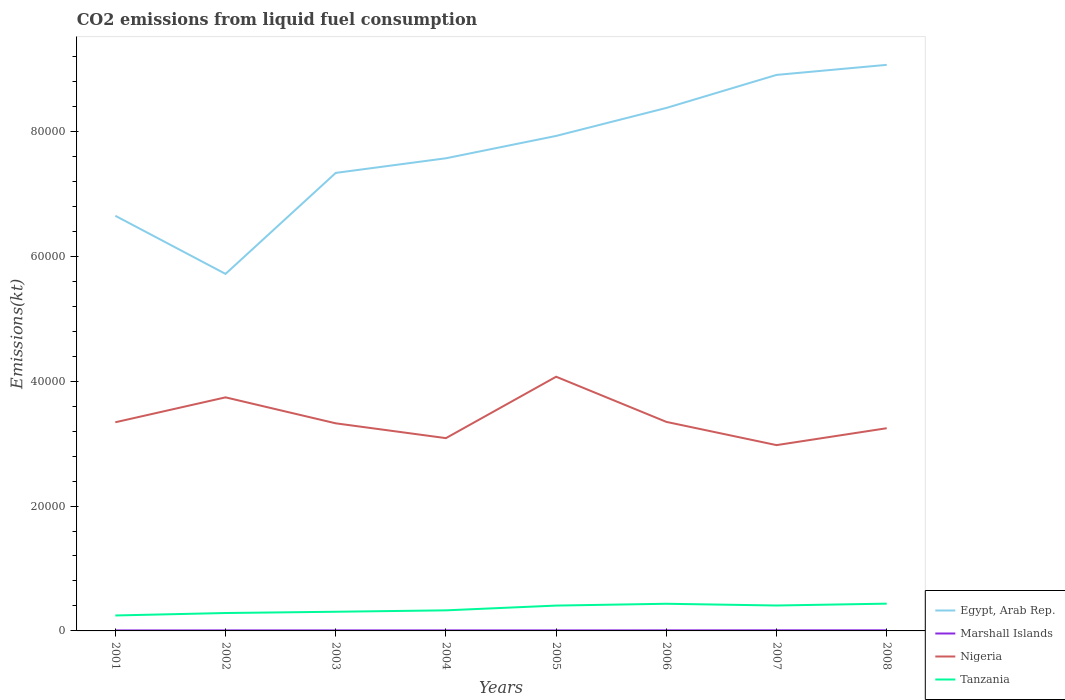Is the number of lines equal to the number of legend labels?
Give a very brief answer. Yes. Across all years, what is the maximum amount of CO2 emitted in Egypt, Arab Rep.?
Ensure brevity in your answer.  5.72e+04. What is the total amount of CO2 emitted in Marshall Islands in the graph?
Offer a terse response. -11. What is the difference between the highest and the second highest amount of CO2 emitted in Marshall Islands?
Ensure brevity in your answer.  18.34. What is the difference between the highest and the lowest amount of CO2 emitted in Egypt, Arab Rep.?
Keep it short and to the point. 4. How many years are there in the graph?
Offer a very short reply. 8. Are the values on the major ticks of Y-axis written in scientific E-notation?
Provide a succinct answer. No. Does the graph contain grids?
Offer a terse response. No. How many legend labels are there?
Make the answer very short. 4. What is the title of the graph?
Give a very brief answer. CO2 emissions from liquid fuel consumption. What is the label or title of the Y-axis?
Your answer should be compact. Emissions(kt). What is the Emissions(kt) of Egypt, Arab Rep. in 2001?
Offer a terse response. 6.65e+04. What is the Emissions(kt) of Marshall Islands in 2001?
Make the answer very short. 80.67. What is the Emissions(kt) of Nigeria in 2001?
Keep it short and to the point. 3.34e+04. What is the Emissions(kt) in Tanzania in 2001?
Offer a very short reply. 2475.22. What is the Emissions(kt) in Egypt, Arab Rep. in 2002?
Ensure brevity in your answer.  5.72e+04. What is the Emissions(kt) of Marshall Islands in 2002?
Offer a terse response. 84.34. What is the Emissions(kt) of Nigeria in 2002?
Make the answer very short. 3.74e+04. What is the Emissions(kt) of Tanzania in 2002?
Offer a terse response. 2867.59. What is the Emissions(kt) in Egypt, Arab Rep. in 2003?
Provide a succinct answer. 7.34e+04. What is the Emissions(kt) in Marshall Islands in 2003?
Your answer should be compact. 84.34. What is the Emissions(kt) in Nigeria in 2003?
Keep it short and to the point. 3.32e+04. What is the Emissions(kt) of Tanzania in 2003?
Your answer should be very brief. 3069.28. What is the Emissions(kt) of Egypt, Arab Rep. in 2004?
Provide a short and direct response. 7.57e+04. What is the Emissions(kt) of Marshall Islands in 2004?
Ensure brevity in your answer.  88.01. What is the Emissions(kt) of Nigeria in 2004?
Keep it short and to the point. 3.09e+04. What is the Emissions(kt) in Tanzania in 2004?
Give a very brief answer. 3296.63. What is the Emissions(kt) of Egypt, Arab Rep. in 2005?
Your answer should be compact. 7.93e+04. What is the Emissions(kt) in Marshall Islands in 2005?
Provide a succinct answer. 84.34. What is the Emissions(kt) in Nigeria in 2005?
Offer a very short reply. 4.07e+04. What is the Emissions(kt) of Tanzania in 2005?
Your response must be concise. 4059.37. What is the Emissions(kt) in Egypt, Arab Rep. in 2006?
Ensure brevity in your answer.  8.38e+04. What is the Emissions(kt) of Marshall Islands in 2006?
Provide a succinct answer. 91.67. What is the Emissions(kt) in Nigeria in 2006?
Offer a very short reply. 3.35e+04. What is the Emissions(kt) in Tanzania in 2006?
Make the answer very short. 4349.06. What is the Emissions(kt) of Egypt, Arab Rep. in 2007?
Offer a terse response. 8.90e+04. What is the Emissions(kt) in Marshall Islands in 2007?
Offer a very short reply. 99.01. What is the Emissions(kt) in Nigeria in 2007?
Provide a succinct answer. 2.98e+04. What is the Emissions(kt) in Tanzania in 2007?
Your response must be concise. 4070.37. What is the Emissions(kt) in Egypt, Arab Rep. in 2008?
Provide a short and direct response. 9.07e+04. What is the Emissions(kt) of Marshall Islands in 2008?
Keep it short and to the point. 99.01. What is the Emissions(kt) in Nigeria in 2008?
Ensure brevity in your answer.  3.25e+04. What is the Emissions(kt) of Tanzania in 2008?
Your answer should be very brief. 4367.4. Across all years, what is the maximum Emissions(kt) of Egypt, Arab Rep.?
Keep it short and to the point. 9.07e+04. Across all years, what is the maximum Emissions(kt) of Marshall Islands?
Keep it short and to the point. 99.01. Across all years, what is the maximum Emissions(kt) of Nigeria?
Offer a terse response. 4.07e+04. Across all years, what is the maximum Emissions(kt) of Tanzania?
Your response must be concise. 4367.4. Across all years, what is the minimum Emissions(kt) in Egypt, Arab Rep.?
Provide a succinct answer. 5.72e+04. Across all years, what is the minimum Emissions(kt) of Marshall Islands?
Your answer should be very brief. 80.67. Across all years, what is the minimum Emissions(kt) in Nigeria?
Keep it short and to the point. 2.98e+04. Across all years, what is the minimum Emissions(kt) in Tanzania?
Provide a short and direct response. 2475.22. What is the total Emissions(kt) of Egypt, Arab Rep. in the graph?
Ensure brevity in your answer.  6.15e+05. What is the total Emissions(kt) in Marshall Islands in the graph?
Provide a short and direct response. 711.4. What is the total Emissions(kt) of Nigeria in the graph?
Provide a succinct answer. 2.71e+05. What is the total Emissions(kt) in Tanzania in the graph?
Your answer should be very brief. 2.86e+04. What is the difference between the Emissions(kt) of Egypt, Arab Rep. in 2001 and that in 2002?
Provide a short and direct response. 9306.85. What is the difference between the Emissions(kt) of Marshall Islands in 2001 and that in 2002?
Offer a terse response. -3.67. What is the difference between the Emissions(kt) in Nigeria in 2001 and that in 2002?
Provide a succinct answer. -3989.7. What is the difference between the Emissions(kt) in Tanzania in 2001 and that in 2002?
Offer a very short reply. -392.37. What is the difference between the Emissions(kt) in Egypt, Arab Rep. in 2001 and that in 2003?
Your answer should be compact. -6868.29. What is the difference between the Emissions(kt) in Marshall Islands in 2001 and that in 2003?
Your answer should be very brief. -3.67. What is the difference between the Emissions(kt) in Nigeria in 2001 and that in 2003?
Your response must be concise. 168.68. What is the difference between the Emissions(kt) of Tanzania in 2001 and that in 2003?
Give a very brief answer. -594.05. What is the difference between the Emissions(kt) of Egypt, Arab Rep. in 2001 and that in 2004?
Your answer should be compact. -9211.5. What is the difference between the Emissions(kt) of Marshall Islands in 2001 and that in 2004?
Your answer should be very brief. -7.33. What is the difference between the Emissions(kt) of Nigeria in 2001 and that in 2004?
Offer a terse response. 2541.23. What is the difference between the Emissions(kt) in Tanzania in 2001 and that in 2004?
Make the answer very short. -821.41. What is the difference between the Emissions(kt) of Egypt, Arab Rep. in 2001 and that in 2005?
Give a very brief answer. -1.28e+04. What is the difference between the Emissions(kt) in Marshall Islands in 2001 and that in 2005?
Make the answer very short. -3.67. What is the difference between the Emissions(kt) of Nigeria in 2001 and that in 2005?
Offer a very short reply. -7293.66. What is the difference between the Emissions(kt) in Tanzania in 2001 and that in 2005?
Provide a short and direct response. -1584.14. What is the difference between the Emissions(kt) in Egypt, Arab Rep. in 2001 and that in 2006?
Make the answer very short. -1.73e+04. What is the difference between the Emissions(kt) in Marshall Islands in 2001 and that in 2006?
Provide a succinct answer. -11. What is the difference between the Emissions(kt) of Nigeria in 2001 and that in 2006?
Offer a terse response. -62.34. What is the difference between the Emissions(kt) of Tanzania in 2001 and that in 2006?
Keep it short and to the point. -1873.84. What is the difference between the Emissions(kt) in Egypt, Arab Rep. in 2001 and that in 2007?
Your answer should be compact. -2.26e+04. What is the difference between the Emissions(kt) of Marshall Islands in 2001 and that in 2007?
Provide a succinct answer. -18.34. What is the difference between the Emissions(kt) in Nigeria in 2001 and that in 2007?
Your response must be concise. 3659.67. What is the difference between the Emissions(kt) of Tanzania in 2001 and that in 2007?
Offer a terse response. -1595.14. What is the difference between the Emissions(kt) in Egypt, Arab Rep. in 2001 and that in 2008?
Give a very brief answer. -2.42e+04. What is the difference between the Emissions(kt) in Marshall Islands in 2001 and that in 2008?
Offer a terse response. -18.34. What is the difference between the Emissions(kt) in Nigeria in 2001 and that in 2008?
Make the answer very short. 953.42. What is the difference between the Emissions(kt) of Tanzania in 2001 and that in 2008?
Keep it short and to the point. -1892.17. What is the difference between the Emissions(kt) in Egypt, Arab Rep. in 2002 and that in 2003?
Keep it short and to the point. -1.62e+04. What is the difference between the Emissions(kt) of Nigeria in 2002 and that in 2003?
Provide a short and direct response. 4158.38. What is the difference between the Emissions(kt) in Tanzania in 2002 and that in 2003?
Offer a very short reply. -201.69. What is the difference between the Emissions(kt) of Egypt, Arab Rep. in 2002 and that in 2004?
Ensure brevity in your answer.  -1.85e+04. What is the difference between the Emissions(kt) of Marshall Islands in 2002 and that in 2004?
Ensure brevity in your answer.  -3.67. What is the difference between the Emissions(kt) in Nigeria in 2002 and that in 2004?
Offer a very short reply. 6530.93. What is the difference between the Emissions(kt) of Tanzania in 2002 and that in 2004?
Offer a very short reply. -429.04. What is the difference between the Emissions(kt) in Egypt, Arab Rep. in 2002 and that in 2005?
Offer a terse response. -2.21e+04. What is the difference between the Emissions(kt) in Marshall Islands in 2002 and that in 2005?
Give a very brief answer. 0. What is the difference between the Emissions(kt) of Nigeria in 2002 and that in 2005?
Keep it short and to the point. -3303.97. What is the difference between the Emissions(kt) of Tanzania in 2002 and that in 2005?
Provide a short and direct response. -1191.78. What is the difference between the Emissions(kt) in Egypt, Arab Rep. in 2002 and that in 2006?
Give a very brief answer. -2.66e+04. What is the difference between the Emissions(kt) in Marshall Islands in 2002 and that in 2006?
Your response must be concise. -7.33. What is the difference between the Emissions(kt) of Nigeria in 2002 and that in 2006?
Your response must be concise. 3927.36. What is the difference between the Emissions(kt) in Tanzania in 2002 and that in 2006?
Offer a very short reply. -1481.47. What is the difference between the Emissions(kt) of Egypt, Arab Rep. in 2002 and that in 2007?
Offer a very short reply. -3.19e+04. What is the difference between the Emissions(kt) of Marshall Islands in 2002 and that in 2007?
Your answer should be compact. -14.67. What is the difference between the Emissions(kt) of Nigeria in 2002 and that in 2007?
Give a very brief answer. 7649.36. What is the difference between the Emissions(kt) of Tanzania in 2002 and that in 2007?
Your answer should be very brief. -1202.78. What is the difference between the Emissions(kt) of Egypt, Arab Rep. in 2002 and that in 2008?
Keep it short and to the point. -3.35e+04. What is the difference between the Emissions(kt) of Marshall Islands in 2002 and that in 2008?
Make the answer very short. -14.67. What is the difference between the Emissions(kt) of Nigeria in 2002 and that in 2008?
Your response must be concise. 4943.12. What is the difference between the Emissions(kt) in Tanzania in 2002 and that in 2008?
Make the answer very short. -1499.8. What is the difference between the Emissions(kt) in Egypt, Arab Rep. in 2003 and that in 2004?
Make the answer very short. -2343.21. What is the difference between the Emissions(kt) of Marshall Islands in 2003 and that in 2004?
Offer a terse response. -3.67. What is the difference between the Emissions(kt) in Nigeria in 2003 and that in 2004?
Offer a very short reply. 2372.55. What is the difference between the Emissions(kt) in Tanzania in 2003 and that in 2004?
Your response must be concise. -227.35. What is the difference between the Emissions(kt) in Egypt, Arab Rep. in 2003 and that in 2005?
Your response must be concise. -5922.2. What is the difference between the Emissions(kt) in Marshall Islands in 2003 and that in 2005?
Your answer should be very brief. 0. What is the difference between the Emissions(kt) of Nigeria in 2003 and that in 2005?
Your answer should be compact. -7462.35. What is the difference between the Emissions(kt) in Tanzania in 2003 and that in 2005?
Your answer should be very brief. -990.09. What is the difference between the Emissions(kt) in Egypt, Arab Rep. in 2003 and that in 2006?
Your response must be concise. -1.04e+04. What is the difference between the Emissions(kt) in Marshall Islands in 2003 and that in 2006?
Your answer should be compact. -7.33. What is the difference between the Emissions(kt) of Nigeria in 2003 and that in 2006?
Provide a succinct answer. -231.02. What is the difference between the Emissions(kt) of Tanzania in 2003 and that in 2006?
Your response must be concise. -1279.78. What is the difference between the Emissions(kt) in Egypt, Arab Rep. in 2003 and that in 2007?
Your answer should be compact. -1.57e+04. What is the difference between the Emissions(kt) in Marshall Islands in 2003 and that in 2007?
Your answer should be compact. -14.67. What is the difference between the Emissions(kt) in Nigeria in 2003 and that in 2007?
Your answer should be compact. 3490.98. What is the difference between the Emissions(kt) of Tanzania in 2003 and that in 2007?
Offer a terse response. -1001.09. What is the difference between the Emissions(kt) in Egypt, Arab Rep. in 2003 and that in 2008?
Your answer should be very brief. -1.73e+04. What is the difference between the Emissions(kt) in Marshall Islands in 2003 and that in 2008?
Offer a terse response. -14.67. What is the difference between the Emissions(kt) of Nigeria in 2003 and that in 2008?
Offer a terse response. 784.74. What is the difference between the Emissions(kt) in Tanzania in 2003 and that in 2008?
Provide a succinct answer. -1298.12. What is the difference between the Emissions(kt) in Egypt, Arab Rep. in 2004 and that in 2005?
Provide a short and direct response. -3578.99. What is the difference between the Emissions(kt) in Marshall Islands in 2004 and that in 2005?
Make the answer very short. 3.67. What is the difference between the Emissions(kt) of Nigeria in 2004 and that in 2005?
Keep it short and to the point. -9834.89. What is the difference between the Emissions(kt) of Tanzania in 2004 and that in 2005?
Offer a very short reply. -762.74. What is the difference between the Emissions(kt) in Egypt, Arab Rep. in 2004 and that in 2006?
Your answer should be very brief. -8060.07. What is the difference between the Emissions(kt) in Marshall Islands in 2004 and that in 2006?
Give a very brief answer. -3.67. What is the difference between the Emissions(kt) of Nigeria in 2004 and that in 2006?
Your response must be concise. -2603.57. What is the difference between the Emissions(kt) of Tanzania in 2004 and that in 2006?
Provide a short and direct response. -1052.43. What is the difference between the Emissions(kt) of Egypt, Arab Rep. in 2004 and that in 2007?
Your answer should be very brief. -1.34e+04. What is the difference between the Emissions(kt) in Marshall Islands in 2004 and that in 2007?
Provide a succinct answer. -11. What is the difference between the Emissions(kt) in Nigeria in 2004 and that in 2007?
Make the answer very short. 1118.43. What is the difference between the Emissions(kt) in Tanzania in 2004 and that in 2007?
Make the answer very short. -773.74. What is the difference between the Emissions(kt) in Egypt, Arab Rep. in 2004 and that in 2008?
Your answer should be compact. -1.50e+04. What is the difference between the Emissions(kt) of Marshall Islands in 2004 and that in 2008?
Offer a terse response. -11. What is the difference between the Emissions(kt) of Nigeria in 2004 and that in 2008?
Ensure brevity in your answer.  -1587.81. What is the difference between the Emissions(kt) in Tanzania in 2004 and that in 2008?
Your answer should be very brief. -1070.76. What is the difference between the Emissions(kt) of Egypt, Arab Rep. in 2005 and that in 2006?
Your answer should be compact. -4481.07. What is the difference between the Emissions(kt) of Marshall Islands in 2005 and that in 2006?
Give a very brief answer. -7.33. What is the difference between the Emissions(kt) in Nigeria in 2005 and that in 2006?
Your answer should be very brief. 7231.32. What is the difference between the Emissions(kt) in Tanzania in 2005 and that in 2006?
Offer a very short reply. -289.69. What is the difference between the Emissions(kt) in Egypt, Arab Rep. in 2005 and that in 2007?
Your answer should be compact. -9772.56. What is the difference between the Emissions(kt) of Marshall Islands in 2005 and that in 2007?
Make the answer very short. -14.67. What is the difference between the Emissions(kt) of Nigeria in 2005 and that in 2007?
Ensure brevity in your answer.  1.10e+04. What is the difference between the Emissions(kt) of Tanzania in 2005 and that in 2007?
Make the answer very short. -11. What is the difference between the Emissions(kt) of Egypt, Arab Rep. in 2005 and that in 2008?
Make the answer very short. -1.14e+04. What is the difference between the Emissions(kt) in Marshall Islands in 2005 and that in 2008?
Provide a short and direct response. -14.67. What is the difference between the Emissions(kt) of Nigeria in 2005 and that in 2008?
Give a very brief answer. 8247.08. What is the difference between the Emissions(kt) in Tanzania in 2005 and that in 2008?
Provide a short and direct response. -308.03. What is the difference between the Emissions(kt) in Egypt, Arab Rep. in 2006 and that in 2007?
Keep it short and to the point. -5291.48. What is the difference between the Emissions(kt) of Marshall Islands in 2006 and that in 2007?
Offer a very short reply. -7.33. What is the difference between the Emissions(kt) of Nigeria in 2006 and that in 2007?
Offer a terse response. 3722.01. What is the difference between the Emissions(kt) of Tanzania in 2006 and that in 2007?
Your answer should be compact. 278.69. What is the difference between the Emissions(kt) of Egypt, Arab Rep. in 2006 and that in 2008?
Offer a terse response. -6901.29. What is the difference between the Emissions(kt) in Marshall Islands in 2006 and that in 2008?
Provide a succinct answer. -7.33. What is the difference between the Emissions(kt) of Nigeria in 2006 and that in 2008?
Offer a terse response. 1015.76. What is the difference between the Emissions(kt) in Tanzania in 2006 and that in 2008?
Ensure brevity in your answer.  -18.34. What is the difference between the Emissions(kt) in Egypt, Arab Rep. in 2007 and that in 2008?
Make the answer very short. -1609.81. What is the difference between the Emissions(kt) of Nigeria in 2007 and that in 2008?
Keep it short and to the point. -2706.25. What is the difference between the Emissions(kt) in Tanzania in 2007 and that in 2008?
Your answer should be very brief. -297.03. What is the difference between the Emissions(kt) in Egypt, Arab Rep. in 2001 and the Emissions(kt) in Marshall Islands in 2002?
Offer a very short reply. 6.64e+04. What is the difference between the Emissions(kt) of Egypt, Arab Rep. in 2001 and the Emissions(kt) of Nigeria in 2002?
Offer a terse response. 2.91e+04. What is the difference between the Emissions(kt) of Egypt, Arab Rep. in 2001 and the Emissions(kt) of Tanzania in 2002?
Give a very brief answer. 6.36e+04. What is the difference between the Emissions(kt) in Marshall Islands in 2001 and the Emissions(kt) in Nigeria in 2002?
Provide a succinct answer. -3.73e+04. What is the difference between the Emissions(kt) of Marshall Islands in 2001 and the Emissions(kt) of Tanzania in 2002?
Your response must be concise. -2786.92. What is the difference between the Emissions(kt) of Nigeria in 2001 and the Emissions(kt) of Tanzania in 2002?
Provide a short and direct response. 3.05e+04. What is the difference between the Emissions(kt) of Egypt, Arab Rep. in 2001 and the Emissions(kt) of Marshall Islands in 2003?
Your answer should be compact. 6.64e+04. What is the difference between the Emissions(kt) of Egypt, Arab Rep. in 2001 and the Emissions(kt) of Nigeria in 2003?
Your answer should be very brief. 3.32e+04. What is the difference between the Emissions(kt) of Egypt, Arab Rep. in 2001 and the Emissions(kt) of Tanzania in 2003?
Your answer should be compact. 6.34e+04. What is the difference between the Emissions(kt) in Marshall Islands in 2001 and the Emissions(kt) in Nigeria in 2003?
Provide a succinct answer. -3.32e+04. What is the difference between the Emissions(kt) in Marshall Islands in 2001 and the Emissions(kt) in Tanzania in 2003?
Your answer should be compact. -2988.61. What is the difference between the Emissions(kt) of Nigeria in 2001 and the Emissions(kt) of Tanzania in 2003?
Your answer should be very brief. 3.03e+04. What is the difference between the Emissions(kt) in Egypt, Arab Rep. in 2001 and the Emissions(kt) in Marshall Islands in 2004?
Give a very brief answer. 6.64e+04. What is the difference between the Emissions(kt) in Egypt, Arab Rep. in 2001 and the Emissions(kt) in Nigeria in 2004?
Ensure brevity in your answer.  3.56e+04. What is the difference between the Emissions(kt) of Egypt, Arab Rep. in 2001 and the Emissions(kt) of Tanzania in 2004?
Provide a short and direct response. 6.32e+04. What is the difference between the Emissions(kt) of Marshall Islands in 2001 and the Emissions(kt) of Nigeria in 2004?
Offer a very short reply. -3.08e+04. What is the difference between the Emissions(kt) in Marshall Islands in 2001 and the Emissions(kt) in Tanzania in 2004?
Your answer should be compact. -3215.96. What is the difference between the Emissions(kt) in Nigeria in 2001 and the Emissions(kt) in Tanzania in 2004?
Give a very brief answer. 3.01e+04. What is the difference between the Emissions(kt) of Egypt, Arab Rep. in 2001 and the Emissions(kt) of Marshall Islands in 2005?
Provide a short and direct response. 6.64e+04. What is the difference between the Emissions(kt) of Egypt, Arab Rep. in 2001 and the Emissions(kt) of Nigeria in 2005?
Give a very brief answer. 2.58e+04. What is the difference between the Emissions(kt) of Egypt, Arab Rep. in 2001 and the Emissions(kt) of Tanzania in 2005?
Your answer should be very brief. 6.24e+04. What is the difference between the Emissions(kt) of Marshall Islands in 2001 and the Emissions(kt) of Nigeria in 2005?
Provide a succinct answer. -4.06e+04. What is the difference between the Emissions(kt) in Marshall Islands in 2001 and the Emissions(kt) in Tanzania in 2005?
Your response must be concise. -3978.7. What is the difference between the Emissions(kt) in Nigeria in 2001 and the Emissions(kt) in Tanzania in 2005?
Make the answer very short. 2.94e+04. What is the difference between the Emissions(kt) in Egypt, Arab Rep. in 2001 and the Emissions(kt) in Marshall Islands in 2006?
Offer a terse response. 6.64e+04. What is the difference between the Emissions(kt) in Egypt, Arab Rep. in 2001 and the Emissions(kt) in Nigeria in 2006?
Ensure brevity in your answer.  3.30e+04. What is the difference between the Emissions(kt) of Egypt, Arab Rep. in 2001 and the Emissions(kt) of Tanzania in 2006?
Give a very brief answer. 6.21e+04. What is the difference between the Emissions(kt) of Marshall Islands in 2001 and the Emissions(kt) of Nigeria in 2006?
Provide a short and direct response. -3.34e+04. What is the difference between the Emissions(kt) in Marshall Islands in 2001 and the Emissions(kt) in Tanzania in 2006?
Your response must be concise. -4268.39. What is the difference between the Emissions(kt) in Nigeria in 2001 and the Emissions(kt) in Tanzania in 2006?
Your response must be concise. 2.91e+04. What is the difference between the Emissions(kt) in Egypt, Arab Rep. in 2001 and the Emissions(kt) in Marshall Islands in 2007?
Give a very brief answer. 6.64e+04. What is the difference between the Emissions(kt) in Egypt, Arab Rep. in 2001 and the Emissions(kt) in Nigeria in 2007?
Give a very brief answer. 3.67e+04. What is the difference between the Emissions(kt) of Egypt, Arab Rep. in 2001 and the Emissions(kt) of Tanzania in 2007?
Provide a short and direct response. 6.24e+04. What is the difference between the Emissions(kt) in Marshall Islands in 2001 and the Emissions(kt) in Nigeria in 2007?
Your answer should be very brief. -2.97e+04. What is the difference between the Emissions(kt) in Marshall Islands in 2001 and the Emissions(kt) in Tanzania in 2007?
Make the answer very short. -3989.7. What is the difference between the Emissions(kt) in Nigeria in 2001 and the Emissions(kt) in Tanzania in 2007?
Ensure brevity in your answer.  2.93e+04. What is the difference between the Emissions(kt) of Egypt, Arab Rep. in 2001 and the Emissions(kt) of Marshall Islands in 2008?
Your answer should be compact. 6.64e+04. What is the difference between the Emissions(kt) of Egypt, Arab Rep. in 2001 and the Emissions(kt) of Nigeria in 2008?
Ensure brevity in your answer.  3.40e+04. What is the difference between the Emissions(kt) of Egypt, Arab Rep. in 2001 and the Emissions(kt) of Tanzania in 2008?
Your answer should be very brief. 6.21e+04. What is the difference between the Emissions(kt) of Marshall Islands in 2001 and the Emissions(kt) of Nigeria in 2008?
Provide a succinct answer. -3.24e+04. What is the difference between the Emissions(kt) of Marshall Islands in 2001 and the Emissions(kt) of Tanzania in 2008?
Provide a short and direct response. -4286.72. What is the difference between the Emissions(kt) of Nigeria in 2001 and the Emissions(kt) of Tanzania in 2008?
Offer a very short reply. 2.90e+04. What is the difference between the Emissions(kt) of Egypt, Arab Rep. in 2002 and the Emissions(kt) of Marshall Islands in 2003?
Keep it short and to the point. 5.71e+04. What is the difference between the Emissions(kt) in Egypt, Arab Rep. in 2002 and the Emissions(kt) in Nigeria in 2003?
Provide a succinct answer. 2.39e+04. What is the difference between the Emissions(kt) of Egypt, Arab Rep. in 2002 and the Emissions(kt) of Tanzania in 2003?
Your response must be concise. 5.41e+04. What is the difference between the Emissions(kt) of Marshall Islands in 2002 and the Emissions(kt) of Nigeria in 2003?
Provide a short and direct response. -3.32e+04. What is the difference between the Emissions(kt) in Marshall Islands in 2002 and the Emissions(kt) in Tanzania in 2003?
Keep it short and to the point. -2984.94. What is the difference between the Emissions(kt) in Nigeria in 2002 and the Emissions(kt) in Tanzania in 2003?
Make the answer very short. 3.43e+04. What is the difference between the Emissions(kt) in Egypt, Arab Rep. in 2002 and the Emissions(kt) in Marshall Islands in 2004?
Provide a short and direct response. 5.71e+04. What is the difference between the Emissions(kt) in Egypt, Arab Rep. in 2002 and the Emissions(kt) in Nigeria in 2004?
Give a very brief answer. 2.63e+04. What is the difference between the Emissions(kt) in Egypt, Arab Rep. in 2002 and the Emissions(kt) in Tanzania in 2004?
Offer a very short reply. 5.39e+04. What is the difference between the Emissions(kt) of Marshall Islands in 2002 and the Emissions(kt) of Nigeria in 2004?
Offer a very short reply. -3.08e+04. What is the difference between the Emissions(kt) of Marshall Islands in 2002 and the Emissions(kt) of Tanzania in 2004?
Offer a terse response. -3212.29. What is the difference between the Emissions(kt) in Nigeria in 2002 and the Emissions(kt) in Tanzania in 2004?
Offer a very short reply. 3.41e+04. What is the difference between the Emissions(kt) of Egypt, Arab Rep. in 2002 and the Emissions(kt) of Marshall Islands in 2005?
Your answer should be compact. 5.71e+04. What is the difference between the Emissions(kt) in Egypt, Arab Rep. in 2002 and the Emissions(kt) in Nigeria in 2005?
Make the answer very short. 1.65e+04. What is the difference between the Emissions(kt) in Egypt, Arab Rep. in 2002 and the Emissions(kt) in Tanzania in 2005?
Ensure brevity in your answer.  5.31e+04. What is the difference between the Emissions(kt) of Marshall Islands in 2002 and the Emissions(kt) of Nigeria in 2005?
Your response must be concise. -4.06e+04. What is the difference between the Emissions(kt) of Marshall Islands in 2002 and the Emissions(kt) of Tanzania in 2005?
Your answer should be very brief. -3975.03. What is the difference between the Emissions(kt) in Nigeria in 2002 and the Emissions(kt) in Tanzania in 2005?
Offer a terse response. 3.33e+04. What is the difference between the Emissions(kt) in Egypt, Arab Rep. in 2002 and the Emissions(kt) in Marshall Islands in 2006?
Provide a short and direct response. 5.71e+04. What is the difference between the Emissions(kt) of Egypt, Arab Rep. in 2002 and the Emissions(kt) of Nigeria in 2006?
Your answer should be very brief. 2.37e+04. What is the difference between the Emissions(kt) of Egypt, Arab Rep. in 2002 and the Emissions(kt) of Tanzania in 2006?
Provide a succinct answer. 5.28e+04. What is the difference between the Emissions(kt) in Marshall Islands in 2002 and the Emissions(kt) in Nigeria in 2006?
Ensure brevity in your answer.  -3.34e+04. What is the difference between the Emissions(kt) in Marshall Islands in 2002 and the Emissions(kt) in Tanzania in 2006?
Provide a succinct answer. -4264.72. What is the difference between the Emissions(kt) of Nigeria in 2002 and the Emissions(kt) of Tanzania in 2006?
Provide a succinct answer. 3.31e+04. What is the difference between the Emissions(kt) of Egypt, Arab Rep. in 2002 and the Emissions(kt) of Marshall Islands in 2007?
Give a very brief answer. 5.71e+04. What is the difference between the Emissions(kt) of Egypt, Arab Rep. in 2002 and the Emissions(kt) of Nigeria in 2007?
Offer a terse response. 2.74e+04. What is the difference between the Emissions(kt) in Egypt, Arab Rep. in 2002 and the Emissions(kt) in Tanzania in 2007?
Your answer should be compact. 5.31e+04. What is the difference between the Emissions(kt) of Marshall Islands in 2002 and the Emissions(kt) of Nigeria in 2007?
Your answer should be very brief. -2.97e+04. What is the difference between the Emissions(kt) of Marshall Islands in 2002 and the Emissions(kt) of Tanzania in 2007?
Keep it short and to the point. -3986.03. What is the difference between the Emissions(kt) in Nigeria in 2002 and the Emissions(kt) in Tanzania in 2007?
Your response must be concise. 3.33e+04. What is the difference between the Emissions(kt) in Egypt, Arab Rep. in 2002 and the Emissions(kt) in Marshall Islands in 2008?
Keep it short and to the point. 5.71e+04. What is the difference between the Emissions(kt) in Egypt, Arab Rep. in 2002 and the Emissions(kt) in Nigeria in 2008?
Give a very brief answer. 2.47e+04. What is the difference between the Emissions(kt) of Egypt, Arab Rep. in 2002 and the Emissions(kt) of Tanzania in 2008?
Your answer should be very brief. 5.28e+04. What is the difference between the Emissions(kt) in Marshall Islands in 2002 and the Emissions(kt) in Nigeria in 2008?
Your answer should be compact. -3.24e+04. What is the difference between the Emissions(kt) of Marshall Islands in 2002 and the Emissions(kt) of Tanzania in 2008?
Provide a short and direct response. -4283.06. What is the difference between the Emissions(kt) in Nigeria in 2002 and the Emissions(kt) in Tanzania in 2008?
Provide a short and direct response. 3.30e+04. What is the difference between the Emissions(kt) of Egypt, Arab Rep. in 2003 and the Emissions(kt) of Marshall Islands in 2004?
Make the answer very short. 7.33e+04. What is the difference between the Emissions(kt) in Egypt, Arab Rep. in 2003 and the Emissions(kt) in Nigeria in 2004?
Provide a succinct answer. 4.25e+04. What is the difference between the Emissions(kt) of Egypt, Arab Rep. in 2003 and the Emissions(kt) of Tanzania in 2004?
Offer a terse response. 7.01e+04. What is the difference between the Emissions(kt) of Marshall Islands in 2003 and the Emissions(kt) of Nigeria in 2004?
Keep it short and to the point. -3.08e+04. What is the difference between the Emissions(kt) of Marshall Islands in 2003 and the Emissions(kt) of Tanzania in 2004?
Your answer should be compact. -3212.29. What is the difference between the Emissions(kt) of Nigeria in 2003 and the Emissions(kt) of Tanzania in 2004?
Offer a very short reply. 3.00e+04. What is the difference between the Emissions(kt) in Egypt, Arab Rep. in 2003 and the Emissions(kt) in Marshall Islands in 2005?
Give a very brief answer. 7.33e+04. What is the difference between the Emissions(kt) of Egypt, Arab Rep. in 2003 and the Emissions(kt) of Nigeria in 2005?
Give a very brief answer. 3.26e+04. What is the difference between the Emissions(kt) in Egypt, Arab Rep. in 2003 and the Emissions(kt) in Tanzania in 2005?
Make the answer very short. 6.93e+04. What is the difference between the Emissions(kt) in Marshall Islands in 2003 and the Emissions(kt) in Nigeria in 2005?
Offer a terse response. -4.06e+04. What is the difference between the Emissions(kt) of Marshall Islands in 2003 and the Emissions(kt) of Tanzania in 2005?
Provide a short and direct response. -3975.03. What is the difference between the Emissions(kt) in Nigeria in 2003 and the Emissions(kt) in Tanzania in 2005?
Your answer should be compact. 2.92e+04. What is the difference between the Emissions(kt) of Egypt, Arab Rep. in 2003 and the Emissions(kt) of Marshall Islands in 2006?
Your response must be concise. 7.33e+04. What is the difference between the Emissions(kt) in Egypt, Arab Rep. in 2003 and the Emissions(kt) in Nigeria in 2006?
Offer a very short reply. 3.99e+04. What is the difference between the Emissions(kt) of Egypt, Arab Rep. in 2003 and the Emissions(kt) of Tanzania in 2006?
Your answer should be compact. 6.90e+04. What is the difference between the Emissions(kt) of Marshall Islands in 2003 and the Emissions(kt) of Nigeria in 2006?
Offer a terse response. -3.34e+04. What is the difference between the Emissions(kt) in Marshall Islands in 2003 and the Emissions(kt) in Tanzania in 2006?
Your response must be concise. -4264.72. What is the difference between the Emissions(kt) in Nigeria in 2003 and the Emissions(kt) in Tanzania in 2006?
Ensure brevity in your answer.  2.89e+04. What is the difference between the Emissions(kt) of Egypt, Arab Rep. in 2003 and the Emissions(kt) of Marshall Islands in 2007?
Offer a terse response. 7.33e+04. What is the difference between the Emissions(kt) of Egypt, Arab Rep. in 2003 and the Emissions(kt) of Nigeria in 2007?
Provide a short and direct response. 4.36e+04. What is the difference between the Emissions(kt) of Egypt, Arab Rep. in 2003 and the Emissions(kt) of Tanzania in 2007?
Your answer should be very brief. 6.93e+04. What is the difference between the Emissions(kt) of Marshall Islands in 2003 and the Emissions(kt) of Nigeria in 2007?
Give a very brief answer. -2.97e+04. What is the difference between the Emissions(kt) of Marshall Islands in 2003 and the Emissions(kt) of Tanzania in 2007?
Make the answer very short. -3986.03. What is the difference between the Emissions(kt) in Nigeria in 2003 and the Emissions(kt) in Tanzania in 2007?
Give a very brief answer. 2.92e+04. What is the difference between the Emissions(kt) of Egypt, Arab Rep. in 2003 and the Emissions(kt) of Marshall Islands in 2008?
Your answer should be very brief. 7.33e+04. What is the difference between the Emissions(kt) of Egypt, Arab Rep. in 2003 and the Emissions(kt) of Nigeria in 2008?
Keep it short and to the point. 4.09e+04. What is the difference between the Emissions(kt) in Egypt, Arab Rep. in 2003 and the Emissions(kt) in Tanzania in 2008?
Provide a succinct answer. 6.90e+04. What is the difference between the Emissions(kt) of Marshall Islands in 2003 and the Emissions(kt) of Nigeria in 2008?
Provide a short and direct response. -3.24e+04. What is the difference between the Emissions(kt) of Marshall Islands in 2003 and the Emissions(kt) of Tanzania in 2008?
Your response must be concise. -4283.06. What is the difference between the Emissions(kt) in Nigeria in 2003 and the Emissions(kt) in Tanzania in 2008?
Your response must be concise. 2.89e+04. What is the difference between the Emissions(kt) of Egypt, Arab Rep. in 2004 and the Emissions(kt) of Marshall Islands in 2005?
Offer a very short reply. 7.56e+04. What is the difference between the Emissions(kt) in Egypt, Arab Rep. in 2004 and the Emissions(kt) in Nigeria in 2005?
Your answer should be very brief. 3.50e+04. What is the difference between the Emissions(kt) of Egypt, Arab Rep. in 2004 and the Emissions(kt) of Tanzania in 2005?
Offer a very short reply. 7.16e+04. What is the difference between the Emissions(kt) of Marshall Islands in 2004 and the Emissions(kt) of Nigeria in 2005?
Your answer should be very brief. -4.06e+04. What is the difference between the Emissions(kt) of Marshall Islands in 2004 and the Emissions(kt) of Tanzania in 2005?
Keep it short and to the point. -3971.36. What is the difference between the Emissions(kt) in Nigeria in 2004 and the Emissions(kt) in Tanzania in 2005?
Provide a succinct answer. 2.68e+04. What is the difference between the Emissions(kt) in Egypt, Arab Rep. in 2004 and the Emissions(kt) in Marshall Islands in 2006?
Offer a terse response. 7.56e+04. What is the difference between the Emissions(kt) in Egypt, Arab Rep. in 2004 and the Emissions(kt) in Nigeria in 2006?
Make the answer very short. 4.22e+04. What is the difference between the Emissions(kt) in Egypt, Arab Rep. in 2004 and the Emissions(kt) in Tanzania in 2006?
Provide a short and direct response. 7.13e+04. What is the difference between the Emissions(kt) in Marshall Islands in 2004 and the Emissions(kt) in Nigeria in 2006?
Offer a terse response. -3.34e+04. What is the difference between the Emissions(kt) in Marshall Islands in 2004 and the Emissions(kt) in Tanzania in 2006?
Give a very brief answer. -4261.05. What is the difference between the Emissions(kt) of Nigeria in 2004 and the Emissions(kt) of Tanzania in 2006?
Your answer should be compact. 2.65e+04. What is the difference between the Emissions(kt) in Egypt, Arab Rep. in 2004 and the Emissions(kt) in Marshall Islands in 2007?
Your answer should be very brief. 7.56e+04. What is the difference between the Emissions(kt) in Egypt, Arab Rep. in 2004 and the Emissions(kt) in Nigeria in 2007?
Offer a terse response. 4.59e+04. What is the difference between the Emissions(kt) in Egypt, Arab Rep. in 2004 and the Emissions(kt) in Tanzania in 2007?
Provide a succinct answer. 7.16e+04. What is the difference between the Emissions(kt) of Marshall Islands in 2004 and the Emissions(kt) of Nigeria in 2007?
Ensure brevity in your answer.  -2.97e+04. What is the difference between the Emissions(kt) in Marshall Islands in 2004 and the Emissions(kt) in Tanzania in 2007?
Make the answer very short. -3982.36. What is the difference between the Emissions(kt) in Nigeria in 2004 and the Emissions(kt) in Tanzania in 2007?
Ensure brevity in your answer.  2.68e+04. What is the difference between the Emissions(kt) of Egypt, Arab Rep. in 2004 and the Emissions(kt) of Marshall Islands in 2008?
Keep it short and to the point. 7.56e+04. What is the difference between the Emissions(kt) of Egypt, Arab Rep. in 2004 and the Emissions(kt) of Nigeria in 2008?
Make the answer very short. 4.32e+04. What is the difference between the Emissions(kt) of Egypt, Arab Rep. in 2004 and the Emissions(kt) of Tanzania in 2008?
Your response must be concise. 7.13e+04. What is the difference between the Emissions(kt) in Marshall Islands in 2004 and the Emissions(kt) in Nigeria in 2008?
Your answer should be compact. -3.24e+04. What is the difference between the Emissions(kt) in Marshall Islands in 2004 and the Emissions(kt) in Tanzania in 2008?
Offer a very short reply. -4279.39. What is the difference between the Emissions(kt) in Nigeria in 2004 and the Emissions(kt) in Tanzania in 2008?
Your answer should be very brief. 2.65e+04. What is the difference between the Emissions(kt) in Egypt, Arab Rep. in 2005 and the Emissions(kt) in Marshall Islands in 2006?
Your response must be concise. 7.92e+04. What is the difference between the Emissions(kt) of Egypt, Arab Rep. in 2005 and the Emissions(kt) of Nigeria in 2006?
Offer a terse response. 4.58e+04. What is the difference between the Emissions(kt) of Egypt, Arab Rep. in 2005 and the Emissions(kt) of Tanzania in 2006?
Your answer should be compact. 7.49e+04. What is the difference between the Emissions(kt) in Marshall Islands in 2005 and the Emissions(kt) in Nigeria in 2006?
Offer a terse response. -3.34e+04. What is the difference between the Emissions(kt) of Marshall Islands in 2005 and the Emissions(kt) of Tanzania in 2006?
Make the answer very short. -4264.72. What is the difference between the Emissions(kt) in Nigeria in 2005 and the Emissions(kt) in Tanzania in 2006?
Ensure brevity in your answer.  3.64e+04. What is the difference between the Emissions(kt) of Egypt, Arab Rep. in 2005 and the Emissions(kt) of Marshall Islands in 2007?
Offer a terse response. 7.92e+04. What is the difference between the Emissions(kt) in Egypt, Arab Rep. in 2005 and the Emissions(kt) in Nigeria in 2007?
Make the answer very short. 4.95e+04. What is the difference between the Emissions(kt) of Egypt, Arab Rep. in 2005 and the Emissions(kt) of Tanzania in 2007?
Give a very brief answer. 7.52e+04. What is the difference between the Emissions(kt) in Marshall Islands in 2005 and the Emissions(kt) in Nigeria in 2007?
Your response must be concise. -2.97e+04. What is the difference between the Emissions(kt) of Marshall Islands in 2005 and the Emissions(kt) of Tanzania in 2007?
Your response must be concise. -3986.03. What is the difference between the Emissions(kt) in Nigeria in 2005 and the Emissions(kt) in Tanzania in 2007?
Provide a succinct answer. 3.66e+04. What is the difference between the Emissions(kt) of Egypt, Arab Rep. in 2005 and the Emissions(kt) of Marshall Islands in 2008?
Offer a very short reply. 7.92e+04. What is the difference between the Emissions(kt) of Egypt, Arab Rep. in 2005 and the Emissions(kt) of Nigeria in 2008?
Your response must be concise. 4.68e+04. What is the difference between the Emissions(kt) of Egypt, Arab Rep. in 2005 and the Emissions(kt) of Tanzania in 2008?
Offer a terse response. 7.49e+04. What is the difference between the Emissions(kt) in Marshall Islands in 2005 and the Emissions(kt) in Nigeria in 2008?
Give a very brief answer. -3.24e+04. What is the difference between the Emissions(kt) in Marshall Islands in 2005 and the Emissions(kt) in Tanzania in 2008?
Make the answer very short. -4283.06. What is the difference between the Emissions(kt) in Nigeria in 2005 and the Emissions(kt) in Tanzania in 2008?
Make the answer very short. 3.63e+04. What is the difference between the Emissions(kt) in Egypt, Arab Rep. in 2006 and the Emissions(kt) in Marshall Islands in 2007?
Provide a short and direct response. 8.37e+04. What is the difference between the Emissions(kt) of Egypt, Arab Rep. in 2006 and the Emissions(kt) of Nigeria in 2007?
Offer a terse response. 5.40e+04. What is the difference between the Emissions(kt) in Egypt, Arab Rep. in 2006 and the Emissions(kt) in Tanzania in 2007?
Give a very brief answer. 7.97e+04. What is the difference between the Emissions(kt) in Marshall Islands in 2006 and the Emissions(kt) in Nigeria in 2007?
Provide a short and direct response. -2.97e+04. What is the difference between the Emissions(kt) of Marshall Islands in 2006 and the Emissions(kt) of Tanzania in 2007?
Your answer should be very brief. -3978.7. What is the difference between the Emissions(kt) of Nigeria in 2006 and the Emissions(kt) of Tanzania in 2007?
Offer a terse response. 2.94e+04. What is the difference between the Emissions(kt) of Egypt, Arab Rep. in 2006 and the Emissions(kt) of Marshall Islands in 2008?
Your answer should be compact. 8.37e+04. What is the difference between the Emissions(kt) in Egypt, Arab Rep. in 2006 and the Emissions(kt) in Nigeria in 2008?
Your response must be concise. 5.13e+04. What is the difference between the Emissions(kt) of Egypt, Arab Rep. in 2006 and the Emissions(kt) of Tanzania in 2008?
Ensure brevity in your answer.  7.94e+04. What is the difference between the Emissions(kt) in Marshall Islands in 2006 and the Emissions(kt) in Nigeria in 2008?
Offer a very short reply. -3.24e+04. What is the difference between the Emissions(kt) of Marshall Islands in 2006 and the Emissions(kt) of Tanzania in 2008?
Your answer should be compact. -4275.72. What is the difference between the Emissions(kt) of Nigeria in 2006 and the Emissions(kt) of Tanzania in 2008?
Provide a short and direct response. 2.91e+04. What is the difference between the Emissions(kt) of Egypt, Arab Rep. in 2007 and the Emissions(kt) of Marshall Islands in 2008?
Provide a succinct answer. 8.90e+04. What is the difference between the Emissions(kt) of Egypt, Arab Rep. in 2007 and the Emissions(kt) of Nigeria in 2008?
Give a very brief answer. 5.66e+04. What is the difference between the Emissions(kt) of Egypt, Arab Rep. in 2007 and the Emissions(kt) of Tanzania in 2008?
Your answer should be compact. 8.47e+04. What is the difference between the Emissions(kt) in Marshall Islands in 2007 and the Emissions(kt) in Nigeria in 2008?
Ensure brevity in your answer.  -3.24e+04. What is the difference between the Emissions(kt) in Marshall Islands in 2007 and the Emissions(kt) in Tanzania in 2008?
Offer a very short reply. -4268.39. What is the difference between the Emissions(kt) of Nigeria in 2007 and the Emissions(kt) of Tanzania in 2008?
Your answer should be very brief. 2.54e+04. What is the average Emissions(kt) of Egypt, Arab Rep. per year?
Keep it short and to the point. 7.69e+04. What is the average Emissions(kt) in Marshall Islands per year?
Ensure brevity in your answer.  88.92. What is the average Emissions(kt) of Nigeria per year?
Ensure brevity in your answer.  3.39e+04. What is the average Emissions(kt) in Tanzania per year?
Keep it short and to the point. 3569.37. In the year 2001, what is the difference between the Emissions(kt) in Egypt, Arab Rep. and Emissions(kt) in Marshall Islands?
Your answer should be very brief. 6.64e+04. In the year 2001, what is the difference between the Emissions(kt) in Egypt, Arab Rep. and Emissions(kt) in Nigeria?
Keep it short and to the point. 3.31e+04. In the year 2001, what is the difference between the Emissions(kt) of Egypt, Arab Rep. and Emissions(kt) of Tanzania?
Provide a succinct answer. 6.40e+04. In the year 2001, what is the difference between the Emissions(kt) of Marshall Islands and Emissions(kt) of Nigeria?
Give a very brief answer. -3.33e+04. In the year 2001, what is the difference between the Emissions(kt) of Marshall Islands and Emissions(kt) of Tanzania?
Your answer should be compact. -2394.55. In the year 2001, what is the difference between the Emissions(kt) of Nigeria and Emissions(kt) of Tanzania?
Ensure brevity in your answer.  3.09e+04. In the year 2002, what is the difference between the Emissions(kt) in Egypt, Arab Rep. and Emissions(kt) in Marshall Islands?
Offer a very short reply. 5.71e+04. In the year 2002, what is the difference between the Emissions(kt) in Egypt, Arab Rep. and Emissions(kt) in Nigeria?
Your response must be concise. 1.98e+04. In the year 2002, what is the difference between the Emissions(kt) in Egypt, Arab Rep. and Emissions(kt) in Tanzania?
Give a very brief answer. 5.43e+04. In the year 2002, what is the difference between the Emissions(kt) of Marshall Islands and Emissions(kt) of Nigeria?
Your answer should be very brief. -3.73e+04. In the year 2002, what is the difference between the Emissions(kt) of Marshall Islands and Emissions(kt) of Tanzania?
Keep it short and to the point. -2783.25. In the year 2002, what is the difference between the Emissions(kt) of Nigeria and Emissions(kt) of Tanzania?
Keep it short and to the point. 3.45e+04. In the year 2003, what is the difference between the Emissions(kt) of Egypt, Arab Rep. and Emissions(kt) of Marshall Islands?
Provide a succinct answer. 7.33e+04. In the year 2003, what is the difference between the Emissions(kt) of Egypt, Arab Rep. and Emissions(kt) of Nigeria?
Provide a succinct answer. 4.01e+04. In the year 2003, what is the difference between the Emissions(kt) in Egypt, Arab Rep. and Emissions(kt) in Tanzania?
Make the answer very short. 7.03e+04. In the year 2003, what is the difference between the Emissions(kt) of Marshall Islands and Emissions(kt) of Nigeria?
Keep it short and to the point. -3.32e+04. In the year 2003, what is the difference between the Emissions(kt) in Marshall Islands and Emissions(kt) in Tanzania?
Ensure brevity in your answer.  -2984.94. In the year 2003, what is the difference between the Emissions(kt) of Nigeria and Emissions(kt) of Tanzania?
Ensure brevity in your answer.  3.02e+04. In the year 2004, what is the difference between the Emissions(kt) of Egypt, Arab Rep. and Emissions(kt) of Marshall Islands?
Offer a terse response. 7.56e+04. In the year 2004, what is the difference between the Emissions(kt) of Egypt, Arab Rep. and Emissions(kt) of Nigeria?
Give a very brief answer. 4.48e+04. In the year 2004, what is the difference between the Emissions(kt) in Egypt, Arab Rep. and Emissions(kt) in Tanzania?
Your answer should be very brief. 7.24e+04. In the year 2004, what is the difference between the Emissions(kt) in Marshall Islands and Emissions(kt) in Nigeria?
Provide a short and direct response. -3.08e+04. In the year 2004, what is the difference between the Emissions(kt) of Marshall Islands and Emissions(kt) of Tanzania?
Offer a very short reply. -3208.62. In the year 2004, what is the difference between the Emissions(kt) of Nigeria and Emissions(kt) of Tanzania?
Keep it short and to the point. 2.76e+04. In the year 2005, what is the difference between the Emissions(kt) in Egypt, Arab Rep. and Emissions(kt) in Marshall Islands?
Offer a terse response. 7.92e+04. In the year 2005, what is the difference between the Emissions(kt) of Egypt, Arab Rep. and Emissions(kt) of Nigeria?
Your answer should be compact. 3.86e+04. In the year 2005, what is the difference between the Emissions(kt) in Egypt, Arab Rep. and Emissions(kt) in Tanzania?
Ensure brevity in your answer.  7.52e+04. In the year 2005, what is the difference between the Emissions(kt) in Marshall Islands and Emissions(kt) in Nigeria?
Your answer should be compact. -4.06e+04. In the year 2005, what is the difference between the Emissions(kt) in Marshall Islands and Emissions(kt) in Tanzania?
Offer a very short reply. -3975.03. In the year 2005, what is the difference between the Emissions(kt) of Nigeria and Emissions(kt) of Tanzania?
Give a very brief answer. 3.67e+04. In the year 2006, what is the difference between the Emissions(kt) in Egypt, Arab Rep. and Emissions(kt) in Marshall Islands?
Offer a terse response. 8.37e+04. In the year 2006, what is the difference between the Emissions(kt) in Egypt, Arab Rep. and Emissions(kt) in Nigeria?
Ensure brevity in your answer.  5.03e+04. In the year 2006, what is the difference between the Emissions(kt) of Egypt, Arab Rep. and Emissions(kt) of Tanzania?
Offer a terse response. 7.94e+04. In the year 2006, what is the difference between the Emissions(kt) of Marshall Islands and Emissions(kt) of Nigeria?
Your answer should be very brief. -3.34e+04. In the year 2006, what is the difference between the Emissions(kt) in Marshall Islands and Emissions(kt) in Tanzania?
Your answer should be compact. -4257.39. In the year 2006, what is the difference between the Emissions(kt) in Nigeria and Emissions(kt) in Tanzania?
Give a very brief answer. 2.91e+04. In the year 2007, what is the difference between the Emissions(kt) of Egypt, Arab Rep. and Emissions(kt) of Marshall Islands?
Give a very brief answer. 8.90e+04. In the year 2007, what is the difference between the Emissions(kt) in Egypt, Arab Rep. and Emissions(kt) in Nigeria?
Provide a short and direct response. 5.93e+04. In the year 2007, what is the difference between the Emissions(kt) in Egypt, Arab Rep. and Emissions(kt) in Tanzania?
Keep it short and to the point. 8.50e+04. In the year 2007, what is the difference between the Emissions(kt) of Marshall Islands and Emissions(kt) of Nigeria?
Your answer should be compact. -2.97e+04. In the year 2007, what is the difference between the Emissions(kt) in Marshall Islands and Emissions(kt) in Tanzania?
Offer a very short reply. -3971.36. In the year 2007, what is the difference between the Emissions(kt) in Nigeria and Emissions(kt) in Tanzania?
Your answer should be compact. 2.57e+04. In the year 2008, what is the difference between the Emissions(kt) of Egypt, Arab Rep. and Emissions(kt) of Marshall Islands?
Give a very brief answer. 9.06e+04. In the year 2008, what is the difference between the Emissions(kt) of Egypt, Arab Rep. and Emissions(kt) of Nigeria?
Ensure brevity in your answer.  5.82e+04. In the year 2008, what is the difference between the Emissions(kt) in Egypt, Arab Rep. and Emissions(kt) in Tanzania?
Your answer should be very brief. 8.63e+04. In the year 2008, what is the difference between the Emissions(kt) in Marshall Islands and Emissions(kt) in Nigeria?
Offer a very short reply. -3.24e+04. In the year 2008, what is the difference between the Emissions(kt) in Marshall Islands and Emissions(kt) in Tanzania?
Your answer should be compact. -4268.39. In the year 2008, what is the difference between the Emissions(kt) in Nigeria and Emissions(kt) in Tanzania?
Your answer should be compact. 2.81e+04. What is the ratio of the Emissions(kt) of Egypt, Arab Rep. in 2001 to that in 2002?
Ensure brevity in your answer.  1.16. What is the ratio of the Emissions(kt) in Marshall Islands in 2001 to that in 2002?
Keep it short and to the point. 0.96. What is the ratio of the Emissions(kt) in Nigeria in 2001 to that in 2002?
Offer a terse response. 0.89. What is the ratio of the Emissions(kt) in Tanzania in 2001 to that in 2002?
Your answer should be compact. 0.86. What is the ratio of the Emissions(kt) of Egypt, Arab Rep. in 2001 to that in 2003?
Provide a succinct answer. 0.91. What is the ratio of the Emissions(kt) of Marshall Islands in 2001 to that in 2003?
Your response must be concise. 0.96. What is the ratio of the Emissions(kt) in Nigeria in 2001 to that in 2003?
Make the answer very short. 1.01. What is the ratio of the Emissions(kt) of Tanzania in 2001 to that in 2003?
Offer a very short reply. 0.81. What is the ratio of the Emissions(kt) in Egypt, Arab Rep. in 2001 to that in 2004?
Provide a short and direct response. 0.88. What is the ratio of the Emissions(kt) of Nigeria in 2001 to that in 2004?
Your answer should be compact. 1.08. What is the ratio of the Emissions(kt) in Tanzania in 2001 to that in 2004?
Offer a terse response. 0.75. What is the ratio of the Emissions(kt) in Egypt, Arab Rep. in 2001 to that in 2005?
Your response must be concise. 0.84. What is the ratio of the Emissions(kt) in Marshall Islands in 2001 to that in 2005?
Your response must be concise. 0.96. What is the ratio of the Emissions(kt) of Nigeria in 2001 to that in 2005?
Make the answer very short. 0.82. What is the ratio of the Emissions(kt) of Tanzania in 2001 to that in 2005?
Offer a very short reply. 0.61. What is the ratio of the Emissions(kt) of Egypt, Arab Rep. in 2001 to that in 2006?
Your answer should be compact. 0.79. What is the ratio of the Emissions(kt) of Marshall Islands in 2001 to that in 2006?
Keep it short and to the point. 0.88. What is the ratio of the Emissions(kt) of Tanzania in 2001 to that in 2006?
Make the answer very short. 0.57. What is the ratio of the Emissions(kt) in Egypt, Arab Rep. in 2001 to that in 2007?
Offer a very short reply. 0.75. What is the ratio of the Emissions(kt) of Marshall Islands in 2001 to that in 2007?
Your answer should be compact. 0.81. What is the ratio of the Emissions(kt) of Nigeria in 2001 to that in 2007?
Provide a short and direct response. 1.12. What is the ratio of the Emissions(kt) of Tanzania in 2001 to that in 2007?
Offer a very short reply. 0.61. What is the ratio of the Emissions(kt) in Egypt, Arab Rep. in 2001 to that in 2008?
Provide a short and direct response. 0.73. What is the ratio of the Emissions(kt) of Marshall Islands in 2001 to that in 2008?
Your response must be concise. 0.81. What is the ratio of the Emissions(kt) of Nigeria in 2001 to that in 2008?
Provide a succinct answer. 1.03. What is the ratio of the Emissions(kt) in Tanzania in 2001 to that in 2008?
Make the answer very short. 0.57. What is the ratio of the Emissions(kt) in Egypt, Arab Rep. in 2002 to that in 2003?
Make the answer very short. 0.78. What is the ratio of the Emissions(kt) in Nigeria in 2002 to that in 2003?
Your answer should be very brief. 1.13. What is the ratio of the Emissions(kt) of Tanzania in 2002 to that in 2003?
Your answer should be compact. 0.93. What is the ratio of the Emissions(kt) in Egypt, Arab Rep. in 2002 to that in 2004?
Keep it short and to the point. 0.76. What is the ratio of the Emissions(kt) of Nigeria in 2002 to that in 2004?
Offer a terse response. 1.21. What is the ratio of the Emissions(kt) in Tanzania in 2002 to that in 2004?
Your response must be concise. 0.87. What is the ratio of the Emissions(kt) in Egypt, Arab Rep. in 2002 to that in 2005?
Ensure brevity in your answer.  0.72. What is the ratio of the Emissions(kt) of Nigeria in 2002 to that in 2005?
Ensure brevity in your answer.  0.92. What is the ratio of the Emissions(kt) in Tanzania in 2002 to that in 2005?
Give a very brief answer. 0.71. What is the ratio of the Emissions(kt) of Egypt, Arab Rep. in 2002 to that in 2006?
Ensure brevity in your answer.  0.68. What is the ratio of the Emissions(kt) in Marshall Islands in 2002 to that in 2006?
Give a very brief answer. 0.92. What is the ratio of the Emissions(kt) of Nigeria in 2002 to that in 2006?
Your response must be concise. 1.12. What is the ratio of the Emissions(kt) in Tanzania in 2002 to that in 2006?
Ensure brevity in your answer.  0.66. What is the ratio of the Emissions(kt) of Egypt, Arab Rep. in 2002 to that in 2007?
Offer a very short reply. 0.64. What is the ratio of the Emissions(kt) of Marshall Islands in 2002 to that in 2007?
Offer a terse response. 0.85. What is the ratio of the Emissions(kt) of Nigeria in 2002 to that in 2007?
Provide a succinct answer. 1.26. What is the ratio of the Emissions(kt) in Tanzania in 2002 to that in 2007?
Make the answer very short. 0.7. What is the ratio of the Emissions(kt) of Egypt, Arab Rep. in 2002 to that in 2008?
Ensure brevity in your answer.  0.63. What is the ratio of the Emissions(kt) in Marshall Islands in 2002 to that in 2008?
Offer a terse response. 0.85. What is the ratio of the Emissions(kt) of Nigeria in 2002 to that in 2008?
Ensure brevity in your answer.  1.15. What is the ratio of the Emissions(kt) in Tanzania in 2002 to that in 2008?
Offer a very short reply. 0.66. What is the ratio of the Emissions(kt) in Marshall Islands in 2003 to that in 2004?
Provide a short and direct response. 0.96. What is the ratio of the Emissions(kt) of Nigeria in 2003 to that in 2004?
Your response must be concise. 1.08. What is the ratio of the Emissions(kt) in Tanzania in 2003 to that in 2004?
Provide a succinct answer. 0.93. What is the ratio of the Emissions(kt) in Egypt, Arab Rep. in 2003 to that in 2005?
Ensure brevity in your answer.  0.93. What is the ratio of the Emissions(kt) of Marshall Islands in 2003 to that in 2005?
Provide a short and direct response. 1. What is the ratio of the Emissions(kt) of Nigeria in 2003 to that in 2005?
Make the answer very short. 0.82. What is the ratio of the Emissions(kt) in Tanzania in 2003 to that in 2005?
Your answer should be compact. 0.76. What is the ratio of the Emissions(kt) of Egypt, Arab Rep. in 2003 to that in 2006?
Keep it short and to the point. 0.88. What is the ratio of the Emissions(kt) in Marshall Islands in 2003 to that in 2006?
Your response must be concise. 0.92. What is the ratio of the Emissions(kt) in Tanzania in 2003 to that in 2006?
Your answer should be very brief. 0.71. What is the ratio of the Emissions(kt) in Egypt, Arab Rep. in 2003 to that in 2007?
Provide a short and direct response. 0.82. What is the ratio of the Emissions(kt) of Marshall Islands in 2003 to that in 2007?
Ensure brevity in your answer.  0.85. What is the ratio of the Emissions(kt) in Nigeria in 2003 to that in 2007?
Provide a succinct answer. 1.12. What is the ratio of the Emissions(kt) of Tanzania in 2003 to that in 2007?
Provide a short and direct response. 0.75. What is the ratio of the Emissions(kt) in Egypt, Arab Rep. in 2003 to that in 2008?
Ensure brevity in your answer.  0.81. What is the ratio of the Emissions(kt) in Marshall Islands in 2003 to that in 2008?
Make the answer very short. 0.85. What is the ratio of the Emissions(kt) of Nigeria in 2003 to that in 2008?
Keep it short and to the point. 1.02. What is the ratio of the Emissions(kt) in Tanzania in 2003 to that in 2008?
Make the answer very short. 0.7. What is the ratio of the Emissions(kt) in Egypt, Arab Rep. in 2004 to that in 2005?
Offer a very short reply. 0.95. What is the ratio of the Emissions(kt) of Marshall Islands in 2004 to that in 2005?
Keep it short and to the point. 1.04. What is the ratio of the Emissions(kt) of Nigeria in 2004 to that in 2005?
Make the answer very short. 0.76. What is the ratio of the Emissions(kt) in Tanzania in 2004 to that in 2005?
Your response must be concise. 0.81. What is the ratio of the Emissions(kt) in Egypt, Arab Rep. in 2004 to that in 2006?
Ensure brevity in your answer.  0.9. What is the ratio of the Emissions(kt) of Marshall Islands in 2004 to that in 2006?
Give a very brief answer. 0.96. What is the ratio of the Emissions(kt) in Nigeria in 2004 to that in 2006?
Provide a short and direct response. 0.92. What is the ratio of the Emissions(kt) in Tanzania in 2004 to that in 2006?
Provide a short and direct response. 0.76. What is the ratio of the Emissions(kt) of Egypt, Arab Rep. in 2004 to that in 2007?
Make the answer very short. 0.85. What is the ratio of the Emissions(kt) of Marshall Islands in 2004 to that in 2007?
Offer a very short reply. 0.89. What is the ratio of the Emissions(kt) in Nigeria in 2004 to that in 2007?
Give a very brief answer. 1.04. What is the ratio of the Emissions(kt) in Tanzania in 2004 to that in 2007?
Ensure brevity in your answer.  0.81. What is the ratio of the Emissions(kt) of Egypt, Arab Rep. in 2004 to that in 2008?
Make the answer very short. 0.83. What is the ratio of the Emissions(kt) in Marshall Islands in 2004 to that in 2008?
Offer a terse response. 0.89. What is the ratio of the Emissions(kt) in Nigeria in 2004 to that in 2008?
Make the answer very short. 0.95. What is the ratio of the Emissions(kt) of Tanzania in 2004 to that in 2008?
Provide a succinct answer. 0.75. What is the ratio of the Emissions(kt) of Egypt, Arab Rep. in 2005 to that in 2006?
Your answer should be compact. 0.95. What is the ratio of the Emissions(kt) in Nigeria in 2005 to that in 2006?
Ensure brevity in your answer.  1.22. What is the ratio of the Emissions(kt) of Tanzania in 2005 to that in 2006?
Your answer should be compact. 0.93. What is the ratio of the Emissions(kt) of Egypt, Arab Rep. in 2005 to that in 2007?
Your answer should be compact. 0.89. What is the ratio of the Emissions(kt) of Marshall Islands in 2005 to that in 2007?
Keep it short and to the point. 0.85. What is the ratio of the Emissions(kt) in Nigeria in 2005 to that in 2007?
Ensure brevity in your answer.  1.37. What is the ratio of the Emissions(kt) in Tanzania in 2005 to that in 2007?
Offer a very short reply. 1. What is the ratio of the Emissions(kt) in Egypt, Arab Rep. in 2005 to that in 2008?
Offer a very short reply. 0.87. What is the ratio of the Emissions(kt) in Marshall Islands in 2005 to that in 2008?
Your answer should be compact. 0.85. What is the ratio of the Emissions(kt) of Nigeria in 2005 to that in 2008?
Give a very brief answer. 1.25. What is the ratio of the Emissions(kt) in Tanzania in 2005 to that in 2008?
Provide a short and direct response. 0.93. What is the ratio of the Emissions(kt) in Egypt, Arab Rep. in 2006 to that in 2007?
Keep it short and to the point. 0.94. What is the ratio of the Emissions(kt) of Marshall Islands in 2006 to that in 2007?
Keep it short and to the point. 0.93. What is the ratio of the Emissions(kt) in Nigeria in 2006 to that in 2007?
Provide a short and direct response. 1.13. What is the ratio of the Emissions(kt) in Tanzania in 2006 to that in 2007?
Provide a short and direct response. 1.07. What is the ratio of the Emissions(kt) in Egypt, Arab Rep. in 2006 to that in 2008?
Offer a terse response. 0.92. What is the ratio of the Emissions(kt) in Marshall Islands in 2006 to that in 2008?
Your answer should be compact. 0.93. What is the ratio of the Emissions(kt) of Nigeria in 2006 to that in 2008?
Your answer should be very brief. 1.03. What is the ratio of the Emissions(kt) in Tanzania in 2006 to that in 2008?
Keep it short and to the point. 1. What is the ratio of the Emissions(kt) of Egypt, Arab Rep. in 2007 to that in 2008?
Your answer should be compact. 0.98. What is the ratio of the Emissions(kt) of Marshall Islands in 2007 to that in 2008?
Offer a very short reply. 1. What is the ratio of the Emissions(kt) of Nigeria in 2007 to that in 2008?
Provide a succinct answer. 0.92. What is the ratio of the Emissions(kt) in Tanzania in 2007 to that in 2008?
Keep it short and to the point. 0.93. What is the difference between the highest and the second highest Emissions(kt) in Egypt, Arab Rep.?
Your response must be concise. 1609.81. What is the difference between the highest and the second highest Emissions(kt) in Nigeria?
Keep it short and to the point. 3303.97. What is the difference between the highest and the second highest Emissions(kt) in Tanzania?
Your response must be concise. 18.34. What is the difference between the highest and the lowest Emissions(kt) of Egypt, Arab Rep.?
Give a very brief answer. 3.35e+04. What is the difference between the highest and the lowest Emissions(kt) in Marshall Islands?
Your answer should be compact. 18.34. What is the difference between the highest and the lowest Emissions(kt) of Nigeria?
Ensure brevity in your answer.  1.10e+04. What is the difference between the highest and the lowest Emissions(kt) in Tanzania?
Keep it short and to the point. 1892.17. 